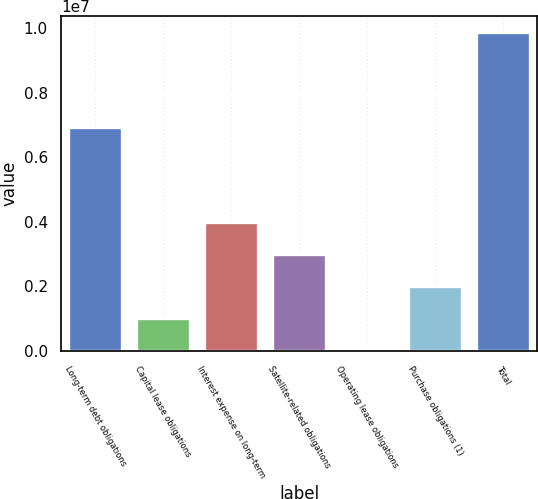<chart> <loc_0><loc_0><loc_500><loc_500><bar_chart><fcel>Long-term debt obligations<fcel>Capital lease obligations<fcel>Interest expense on long-term<fcel>Satellite-related obligations<fcel>Operating lease obligations<fcel>Purchase obligations (1)<fcel>Total<nl><fcel>6.95097e+06<fcel>1.02872e+06<fcel>3.97936e+06<fcel>2.99581e+06<fcel>45175<fcel>2.01227e+06<fcel>9.88063e+06<nl></chart> 